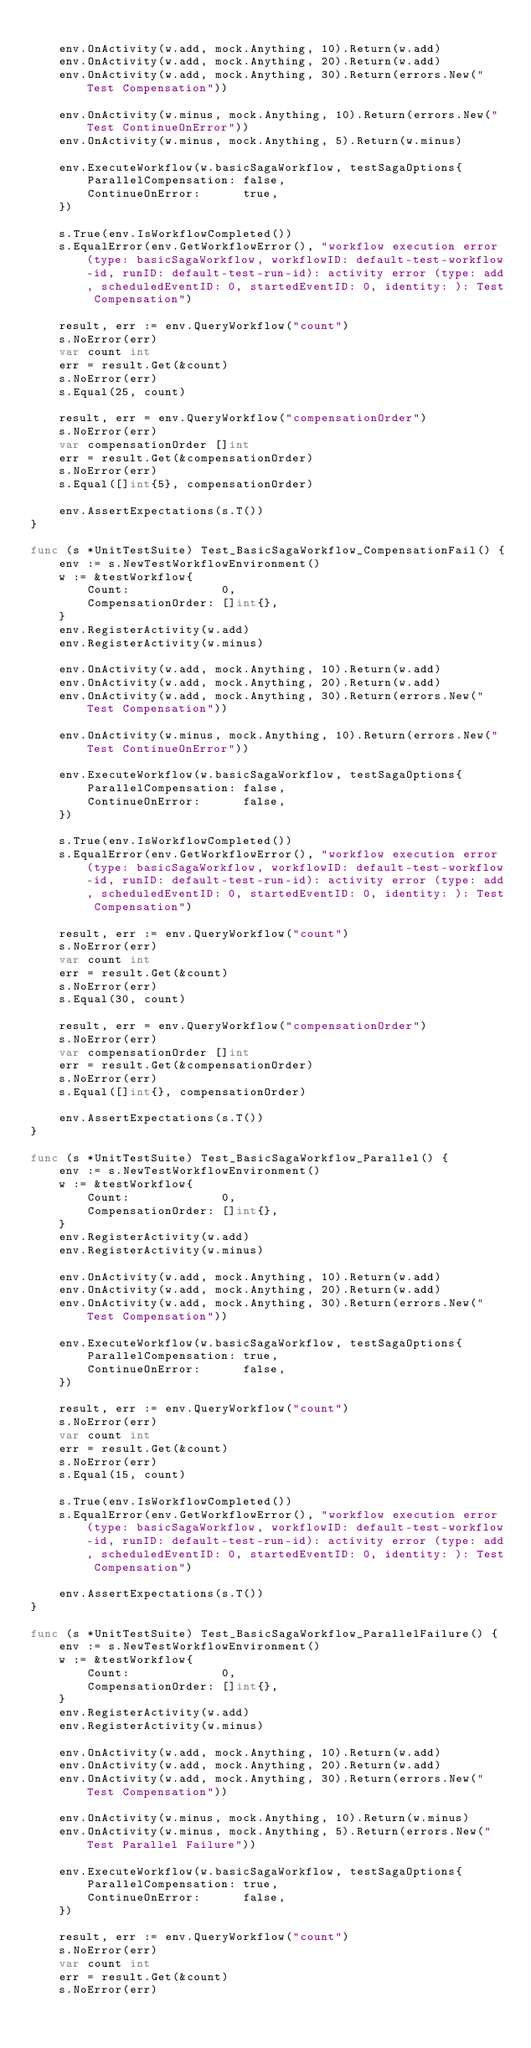<code> <loc_0><loc_0><loc_500><loc_500><_Go_>
	env.OnActivity(w.add, mock.Anything, 10).Return(w.add)
	env.OnActivity(w.add, mock.Anything, 20).Return(w.add)
	env.OnActivity(w.add, mock.Anything, 30).Return(errors.New("Test Compensation"))

	env.OnActivity(w.minus, mock.Anything, 10).Return(errors.New("Test ContinueOnError"))
	env.OnActivity(w.minus, mock.Anything, 5).Return(w.minus)

	env.ExecuteWorkflow(w.basicSagaWorkflow, testSagaOptions{
		ParallelCompensation: false,
		ContinueOnError:      true,
	})

	s.True(env.IsWorkflowCompleted())
	s.EqualError(env.GetWorkflowError(), "workflow execution error (type: basicSagaWorkflow, workflowID: default-test-workflow-id, runID: default-test-run-id): activity error (type: add, scheduledEventID: 0, startedEventID: 0, identity: ): Test Compensation")

	result, err := env.QueryWorkflow("count")
	s.NoError(err)
	var count int
	err = result.Get(&count)
	s.NoError(err)
	s.Equal(25, count)

	result, err = env.QueryWorkflow("compensationOrder")
	s.NoError(err)
	var compensationOrder []int
	err = result.Get(&compensationOrder)
	s.NoError(err)
	s.Equal([]int{5}, compensationOrder)

	env.AssertExpectations(s.T())
}

func (s *UnitTestSuite) Test_BasicSagaWorkflow_CompensationFail() {
	env := s.NewTestWorkflowEnvironment()
	w := &testWorkflow{
		Count:             0,
		CompensationOrder: []int{},
	}
	env.RegisterActivity(w.add)
	env.RegisterActivity(w.minus)

	env.OnActivity(w.add, mock.Anything, 10).Return(w.add)
	env.OnActivity(w.add, mock.Anything, 20).Return(w.add)
	env.OnActivity(w.add, mock.Anything, 30).Return(errors.New("Test Compensation"))

	env.OnActivity(w.minus, mock.Anything, 10).Return(errors.New("Test ContinueOnError"))

	env.ExecuteWorkflow(w.basicSagaWorkflow, testSagaOptions{
		ParallelCompensation: false,
		ContinueOnError:      false,
	})

	s.True(env.IsWorkflowCompleted())
	s.EqualError(env.GetWorkflowError(), "workflow execution error (type: basicSagaWorkflow, workflowID: default-test-workflow-id, runID: default-test-run-id): activity error (type: add, scheduledEventID: 0, startedEventID: 0, identity: ): Test Compensation")

	result, err := env.QueryWorkflow("count")
	s.NoError(err)
	var count int
	err = result.Get(&count)
	s.NoError(err)
	s.Equal(30, count)

	result, err = env.QueryWorkflow("compensationOrder")
	s.NoError(err)
	var compensationOrder []int
	err = result.Get(&compensationOrder)
	s.NoError(err)
	s.Equal([]int{}, compensationOrder)

	env.AssertExpectations(s.T())
}

func (s *UnitTestSuite) Test_BasicSagaWorkflow_Parallel() {
	env := s.NewTestWorkflowEnvironment()
	w := &testWorkflow{
		Count:             0,
		CompensationOrder: []int{},
	}
	env.RegisterActivity(w.add)
	env.RegisterActivity(w.minus)

	env.OnActivity(w.add, mock.Anything, 10).Return(w.add)
	env.OnActivity(w.add, mock.Anything, 20).Return(w.add)
	env.OnActivity(w.add, mock.Anything, 30).Return(errors.New("Test Compensation"))

	env.ExecuteWorkflow(w.basicSagaWorkflow, testSagaOptions{
		ParallelCompensation: true,
		ContinueOnError:      false,
	})

	result, err := env.QueryWorkflow("count")
	s.NoError(err)
	var count int
	err = result.Get(&count)
	s.NoError(err)
	s.Equal(15, count)

	s.True(env.IsWorkflowCompleted())
	s.EqualError(env.GetWorkflowError(), "workflow execution error (type: basicSagaWorkflow, workflowID: default-test-workflow-id, runID: default-test-run-id): activity error (type: add, scheduledEventID: 0, startedEventID: 0, identity: ): Test Compensation")

	env.AssertExpectations(s.T())
}

func (s *UnitTestSuite) Test_BasicSagaWorkflow_ParallelFailure() {
	env := s.NewTestWorkflowEnvironment()
	w := &testWorkflow{
		Count:             0,
		CompensationOrder: []int{},
	}
	env.RegisterActivity(w.add)
	env.RegisterActivity(w.minus)

	env.OnActivity(w.add, mock.Anything, 10).Return(w.add)
	env.OnActivity(w.add, mock.Anything, 20).Return(w.add)
	env.OnActivity(w.add, mock.Anything, 30).Return(errors.New("Test Compensation"))

	env.OnActivity(w.minus, mock.Anything, 10).Return(w.minus)
	env.OnActivity(w.minus, mock.Anything, 5).Return(errors.New("Test Parallel Failure"))

	env.ExecuteWorkflow(w.basicSagaWorkflow, testSagaOptions{
		ParallelCompensation: true,
		ContinueOnError:      false,
	})

	result, err := env.QueryWorkflow("count")
	s.NoError(err)
	var count int
	err = result.Get(&count)
	s.NoError(err)</code> 